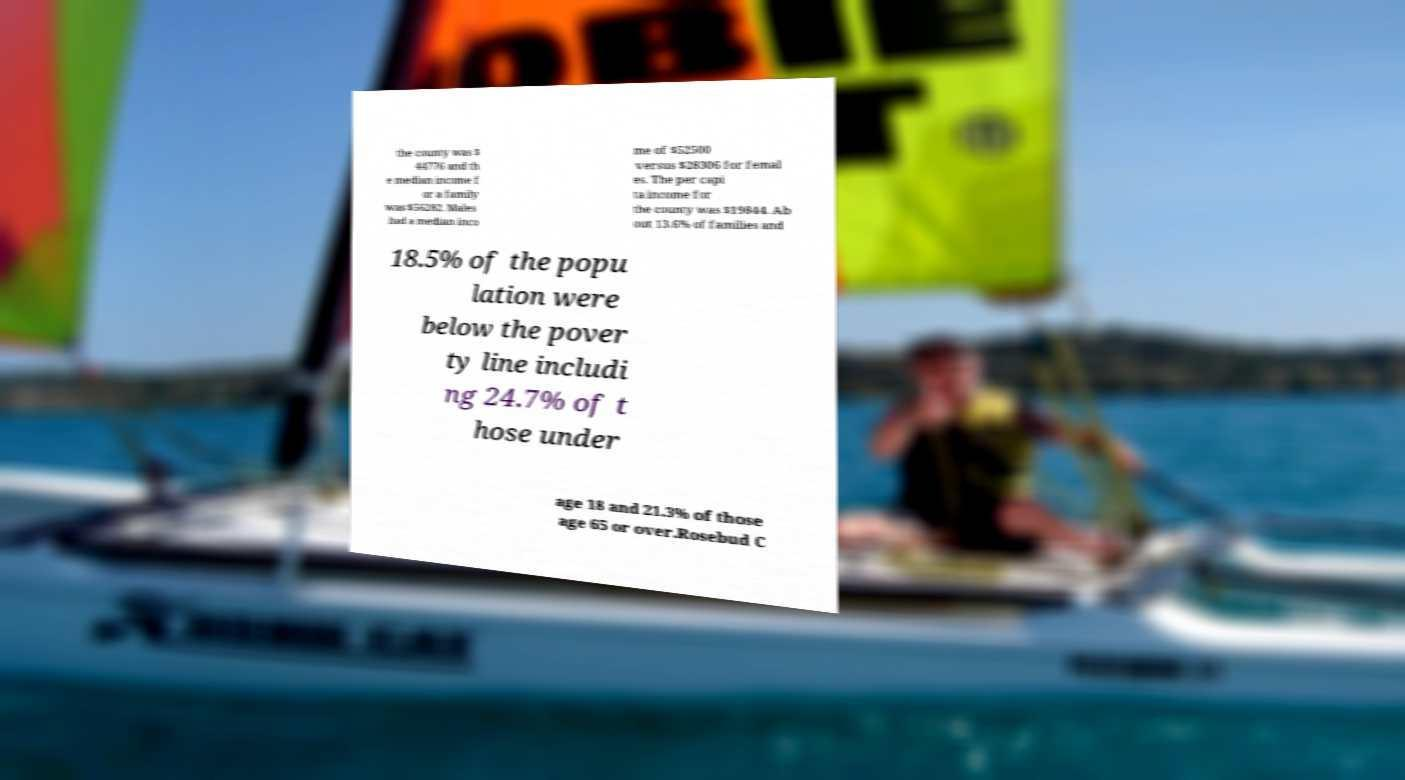Could you extract and type out the text from this image? the county was $ 44776 and th e median income f or a family was $56282. Males had a median inco me of $52500 versus $28306 for femal es. The per capi ta income for the county was $19844. Ab out 13.6% of families and 18.5% of the popu lation were below the pover ty line includi ng 24.7% of t hose under age 18 and 21.3% of those age 65 or over.Rosebud C 